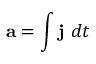<formula> <loc_0><loc_0><loc_500><loc_500>a = \int j \ d t</formula> 